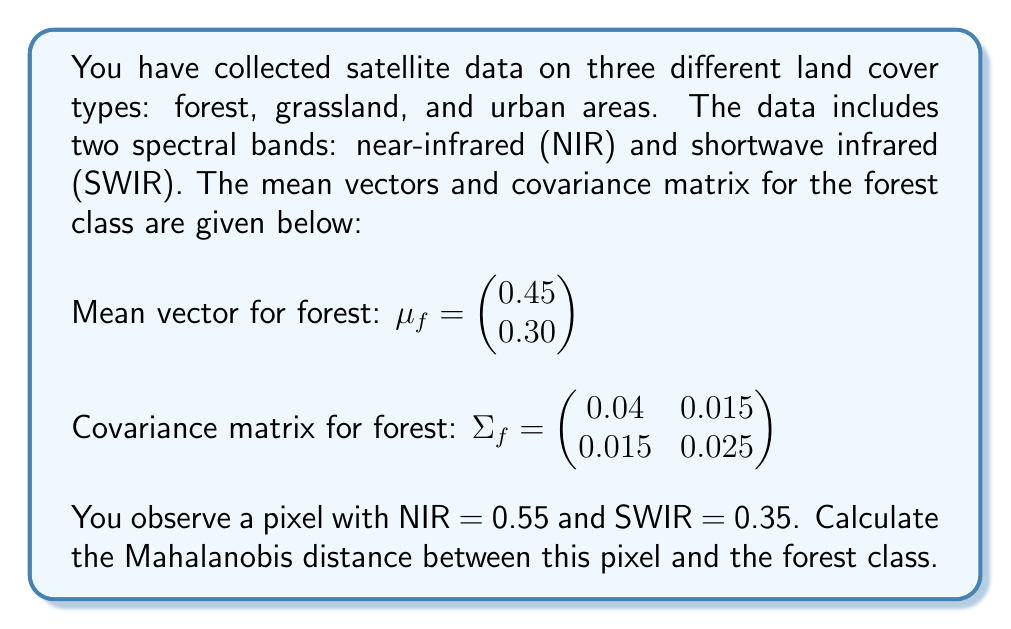Teach me how to tackle this problem. To solve this problem, we'll follow these steps:

1) The Mahalanobis distance is given by the formula:

   $$ D_M = \sqrt{(x - \mu)^T \Sigma^{-1} (x - \mu)} $$

   where $x$ is the observed vector, $\mu$ is the mean vector, and $\Sigma$ is the covariance matrix.

2) We have:
   $x = \begin{pmatrix} 0.55 \\ 0.35 \end{pmatrix}$, 
   $\mu_f = \begin{pmatrix} 0.45 \\ 0.30 \end{pmatrix}$, 
   $\Sigma_f = \begin{pmatrix} 0.04 & 0.015 \\ 0.015 & 0.025 \end{pmatrix}$

3) First, we need to calculate $\Sigma_f^{-1}$:
   
   $$ \Sigma_f^{-1} = \frac{1}{0.04 \times 0.025 - 0.015^2} \begin{pmatrix} 0.025 & -0.015 \\ -0.015 & 0.04 \end{pmatrix} = \begin{pmatrix} 28.57 & -17.14 \\ -17.14 & 45.71 \end{pmatrix} $$

4) Next, we calculate $(x - \mu_f)$:
   
   $$ x - \mu_f = \begin{pmatrix} 0.55 \\ 0.35 \end{pmatrix} - \begin{pmatrix} 0.45 \\ 0.30 \end{pmatrix} = \begin{pmatrix} 0.10 \\ 0.05 \end{pmatrix} $$

5) Now we can calculate $(x - \mu_f)^T \Sigma_f^{-1} (x - \mu_f)$:

   $$ \begin{pmatrix} 0.10 & 0.05 \end{pmatrix} \begin{pmatrix} 28.57 & -17.14 \\ -17.14 & 45.71 \end{pmatrix} \begin{pmatrix} 0.10 \\ 0.05 \end{pmatrix} $$

   $$ = \begin{pmatrix} 0.10 & 0.05 \end{pmatrix} \begin{pmatrix} 2.857 - 0.857 \\ -1.714 + 2.2855 \end{pmatrix} $$

   $$ = (0.10 \times 2) + (0.05 \times 0.5715) = 0.228575 $$

6) Finally, we take the square root:

   $$ D_M = \sqrt{0.228575} \approx 0.4781 $$
Answer: The Mahalanobis distance between the observed pixel and the forest class is approximately 0.4781. 